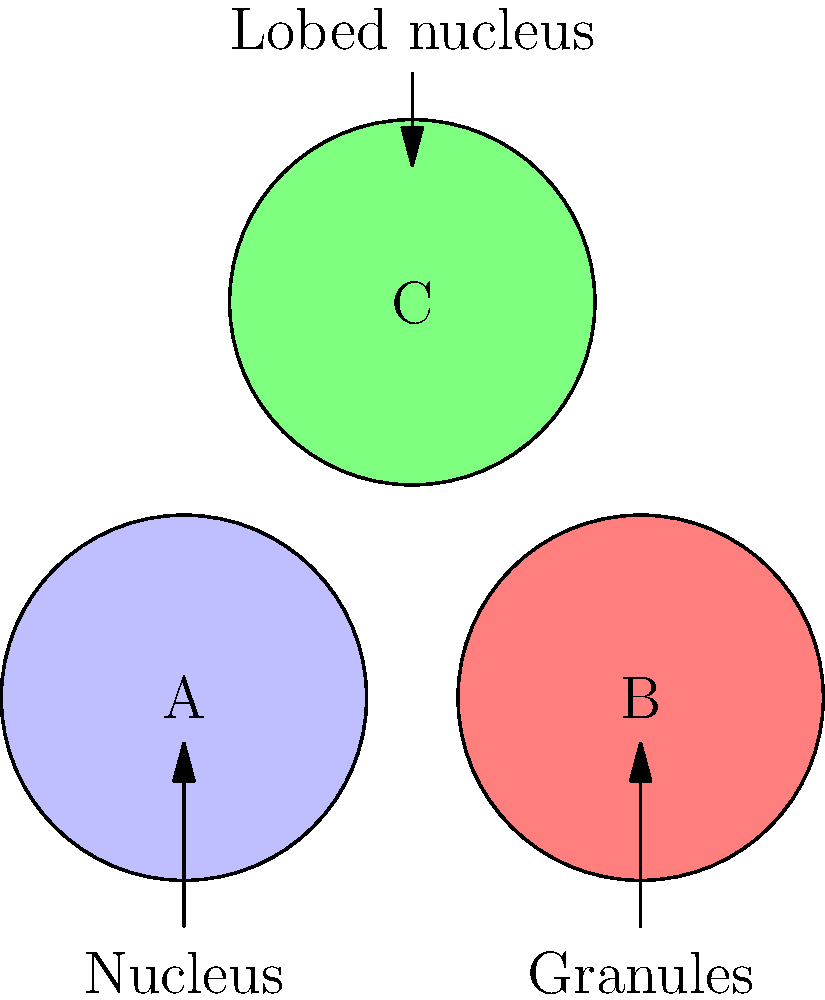Identify the white blood cell types represented by A, B, and C in the microscope image above. Which cell is most likely a neutrophil? To identify the neutrophil, we need to analyze the characteristics of each cell:

1. Cell A: This cell has a single, round nucleus without visible granules. These features are typical of lymphocytes.

2. Cell B: This cell has visible granules in the cytoplasm and a single, round nucleus. These characteristics are consistent with basophils or eosinophils.

3. Cell C: This cell has a multi-lobed nucleus (typically 2-5 lobes) and faint granules in the cytoplasm. These features are distinctive of neutrophils.

Neutrophils are characterized by:
- A multi-lobed nucleus (usually 2-5 lobes)
- Pale, finely granulated cytoplasm
- Medium size (10-12 μm in diameter)

Based on these characteristics, cell C most closely resembles a neutrophil due to its lobed nucleus and faint granulation.
Answer: C 